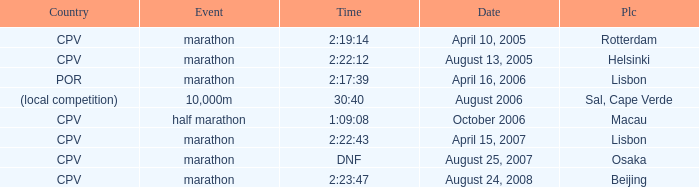What is the Place of the Event on August 25, 2007? Osaka. 